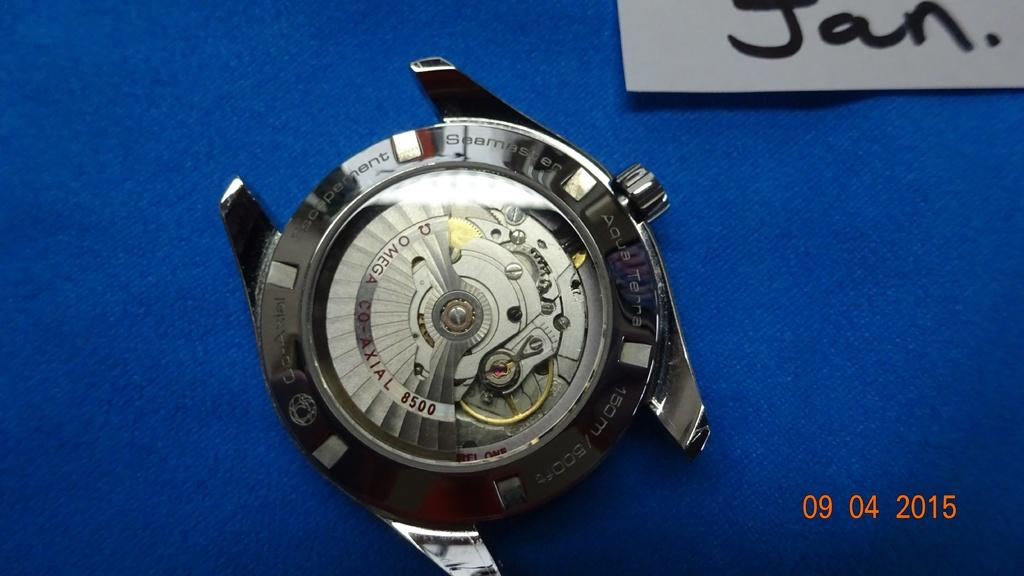<image>
Write a terse but informative summary of the picture. A photo of the back of a watch on a blue background taken in 2015. 